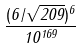<formula> <loc_0><loc_0><loc_500><loc_500>\frac { ( 6 / \sqrt { 2 0 9 } ) ^ { 6 } } { 1 0 ^ { 1 6 9 } }</formula> 